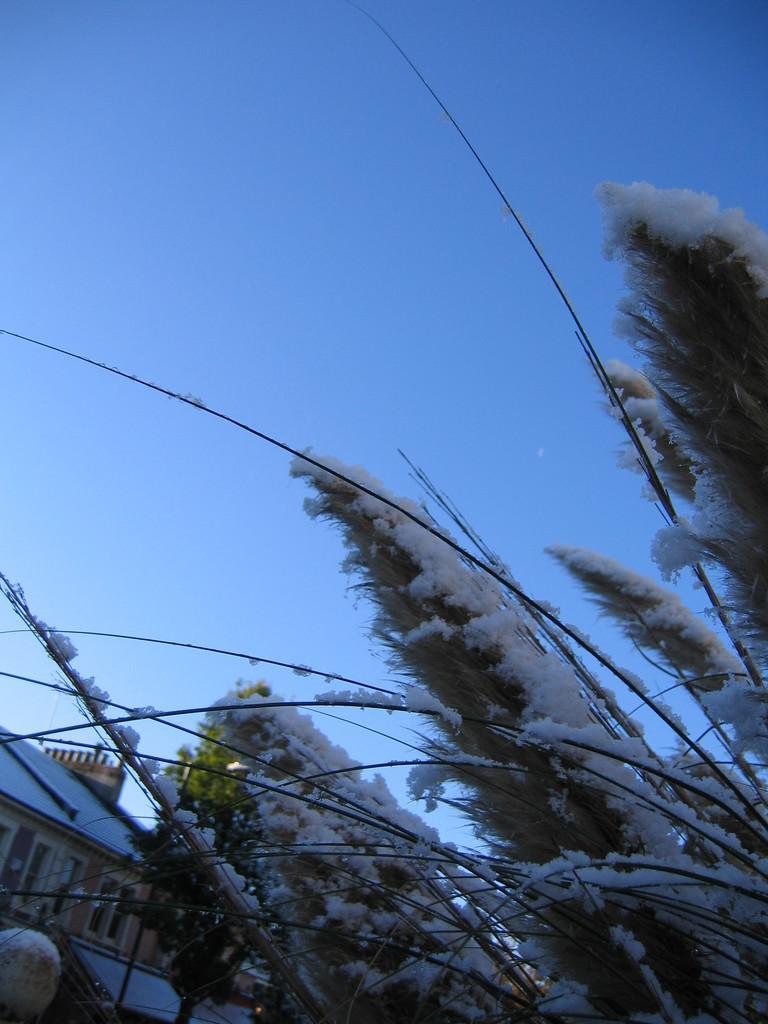Please provide a concise description of this image. In this image we can see the building. We can also see the tree which is covered with the snow. In the background sky is visible. 